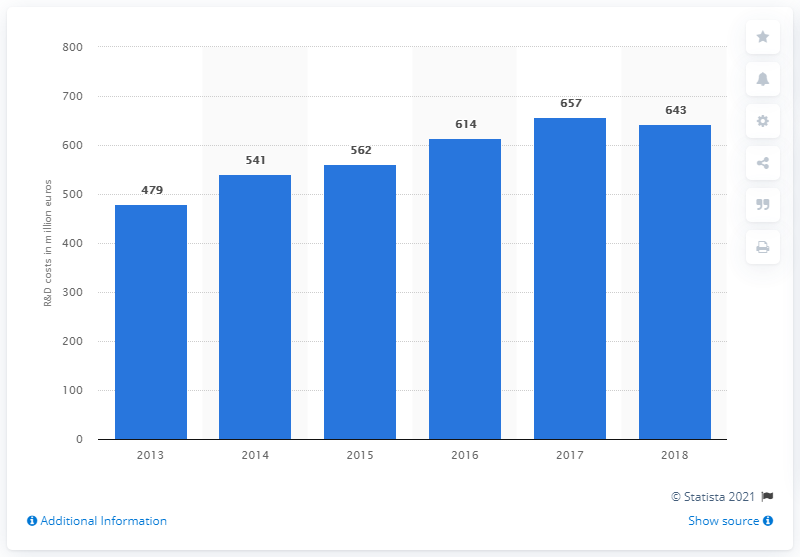What was Ferrari's R&D expenditure in 2017?
 657 